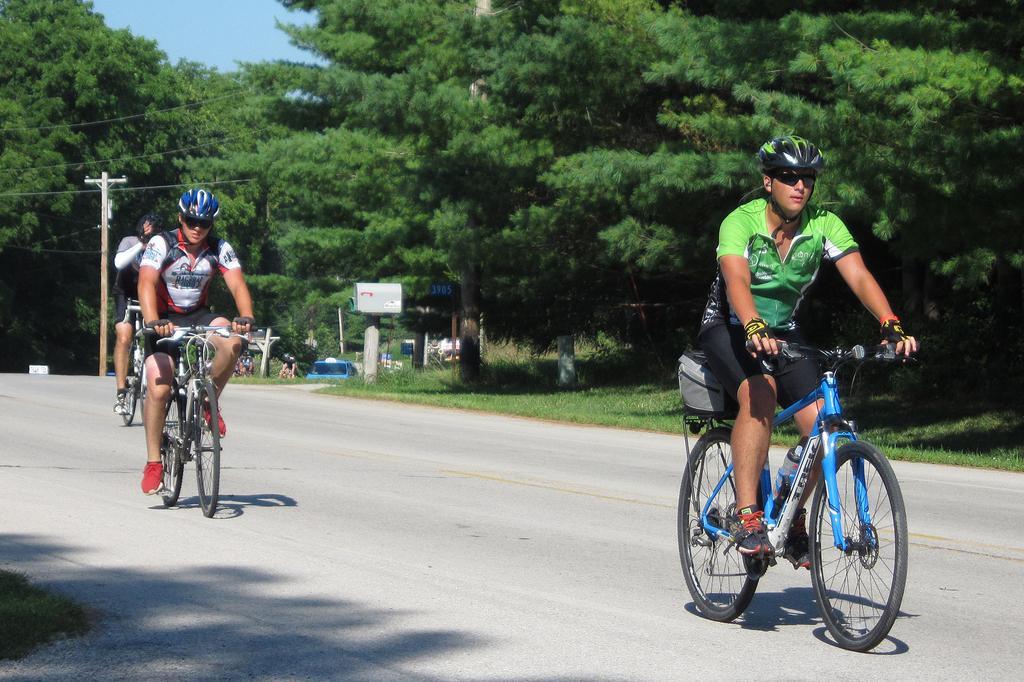Describe this image in one or two sentences. In this image, there are a few people riding bicycles. We can see the ground with some objects. There are a few trees and poles with wires. We can see some grass and a blue colored object. We can see the sky. 